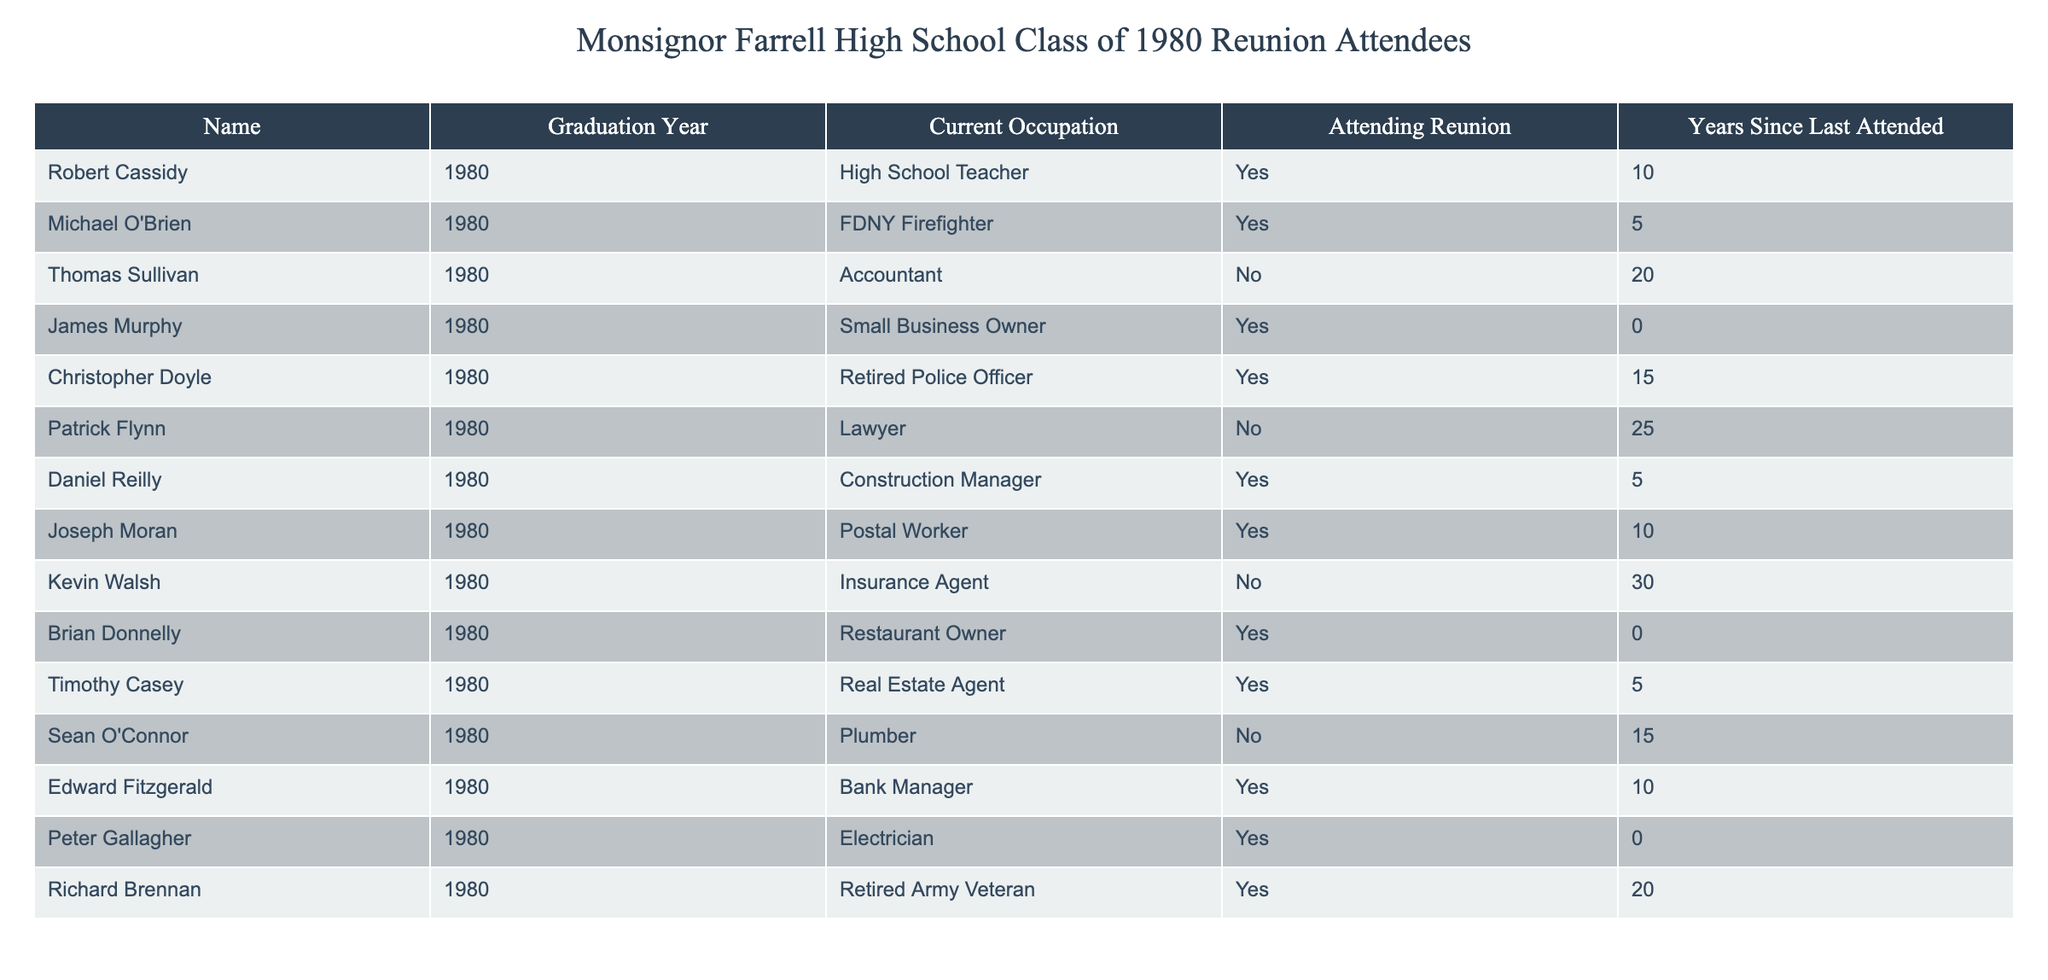What is the current occupation of Robert Cassidy? In the table, the row corresponding to Robert Cassidy shows his current occupation listed as "High School Teacher."
Answer: High School Teacher How many classmates are attending the reunion? By reviewing the "Attending Reunion" column, I count the entries marked "Yes." There are a total of six people attending the reunion.
Answer: 6 What is the total number of years since the last attended reunion for those attending this time? I look at the "Years Since Last Attended" column for only those marked "Yes" in the "Attending Reunion" column. The years are 10, 5, 0, 15, 5, 10, 0, and 20. Adding these values (10 + 5 + 0 + 15 + 5 + 10 + 0 + 20) gives a total of 65 years.
Answer: 65 Which occupation is represented the most among those not attending the reunion? I check the "Current Occupation" of those marked "No" in the "Attending Reunion" column. The occupations are Lawyer, Accountant, and Plumber. Each occupation is mentioned only once, indicating no repetition in this group.
Answer: No occupation is repeated Is there anyone with the current occupation of Postal Worker attending the reunion? I look at the "Current Occupation" of all attendees marked "Yes." Joseph Moran has the occupation listed as "Postal Worker," confirming that he is attending the reunion.
Answer: Yes How many years has it been since the last attended reunion for the person with the shortest time since last attending? In the "Years Since Last Attended" column, I look for the minimum value among those marked "Yes." The shortest time listed is "0" for James Murphy, Brian Donnelly, and Peter Gallagher. All three have not attended in the last reunion.
Answer: 0 How many attendees have current occupations that are related to public services (like firefighting or police)? I examine the "Current Occupation" of those attending and find Michael O'Brien (FDNY Firefighter) and Christopher Doyle (Retired Police Officer) whose occupations fall under public service. That totals to two attendees engaged in public service.
Answer: 2 Which attendee has not attended the reunion for the longest time? I check the "Years Since Last Attended" column for the maximum value among those marked "No." Patrick Flynn has not attended for 25 years, which is the longest recorded time not attending.
Answer: Patrick Flynn 